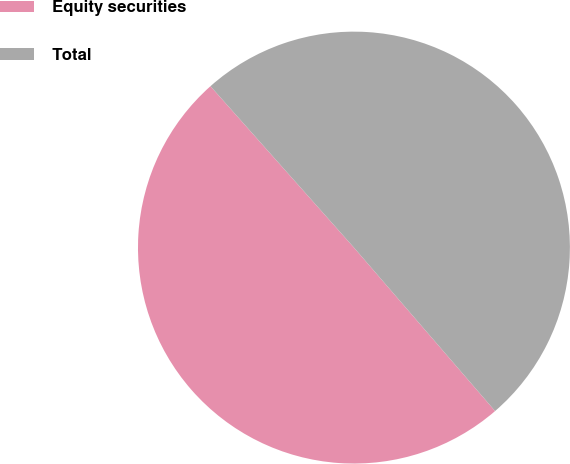Convert chart to OTSL. <chart><loc_0><loc_0><loc_500><loc_500><pie_chart><fcel>Equity securities<fcel>Total<nl><fcel>49.77%<fcel>50.23%<nl></chart> 